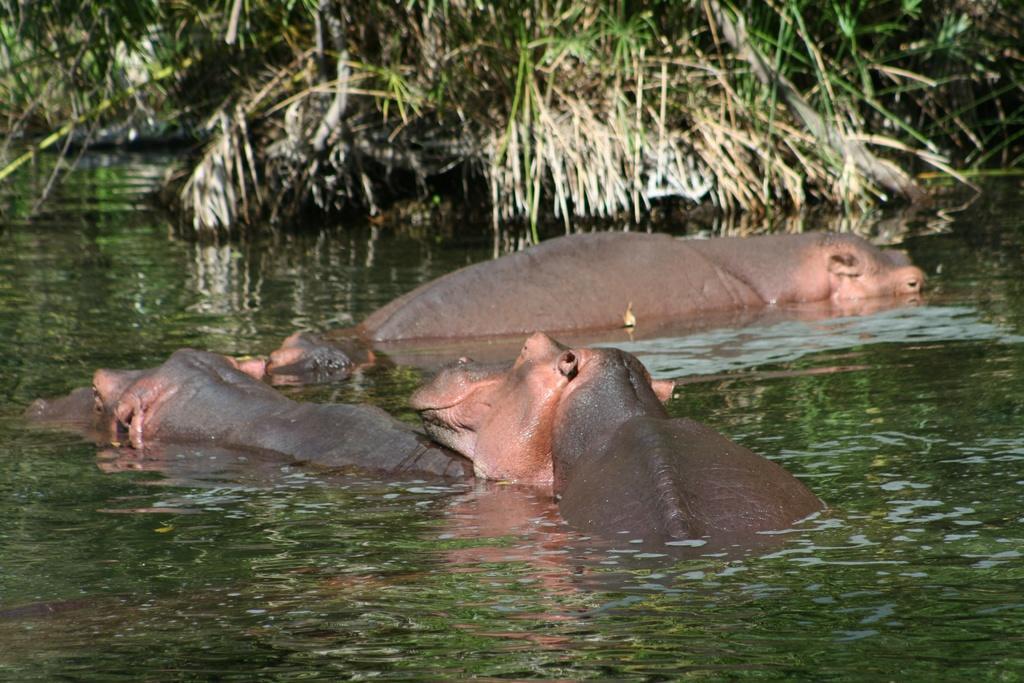Please provide a concise description of this image. In this image we can see hippopotamuses in the water. In the back there are plants. 